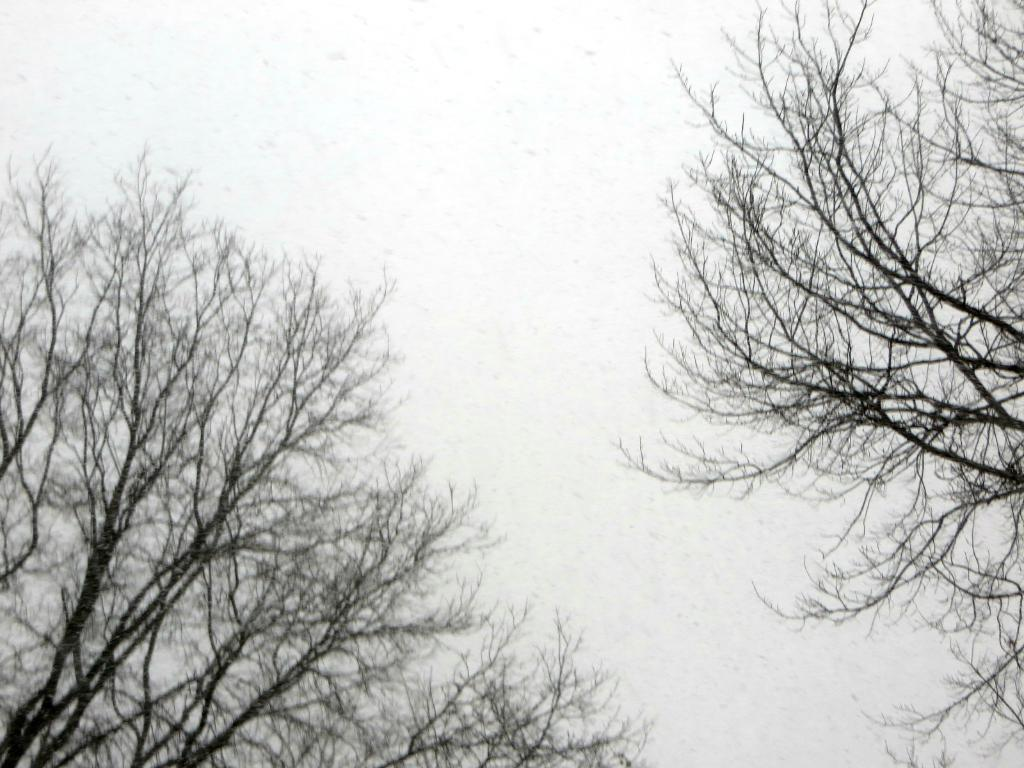What type of vegetation can be seen on both sides of the image? There are trees on either side of the image. What color is the background of the image? The background of the image is white in color. What type of sound can be heard coming from the trees in the image? There is no sound present in the image, as it is a still image and not a video or audio recording. 